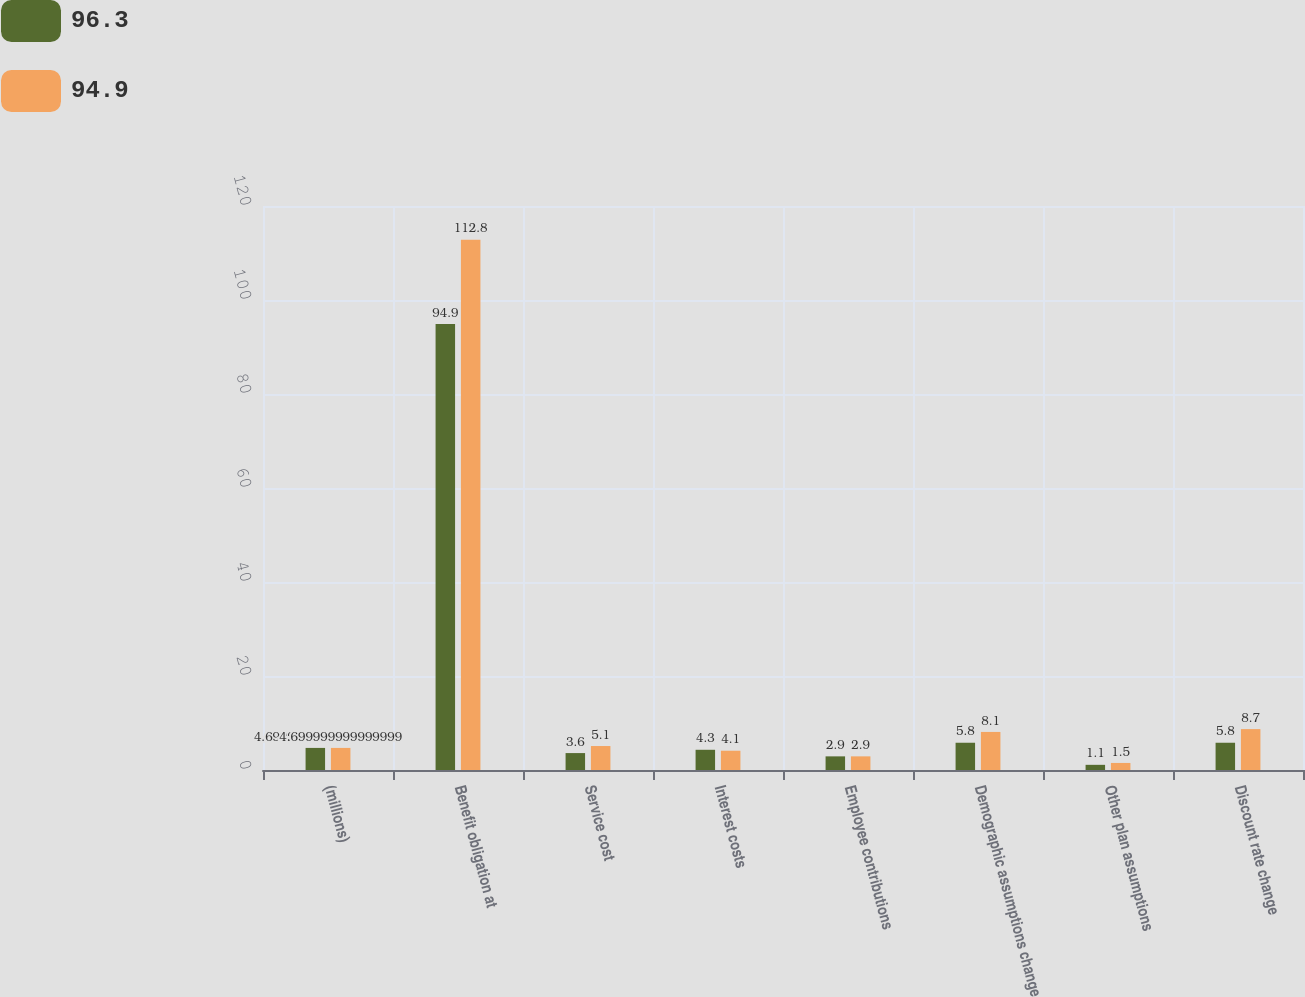Convert chart to OTSL. <chart><loc_0><loc_0><loc_500><loc_500><stacked_bar_chart><ecel><fcel>(millions)<fcel>Benefit obligation at<fcel>Service cost<fcel>Interest costs<fcel>Employee contributions<fcel>Demographic assumptions change<fcel>Other plan assumptions<fcel>Discount rate change<nl><fcel>96.3<fcel>4.7<fcel>94.9<fcel>3.6<fcel>4.3<fcel>2.9<fcel>5.8<fcel>1.1<fcel>5.8<nl><fcel>94.9<fcel>4.7<fcel>112.8<fcel>5.1<fcel>4.1<fcel>2.9<fcel>8.1<fcel>1.5<fcel>8.7<nl></chart> 